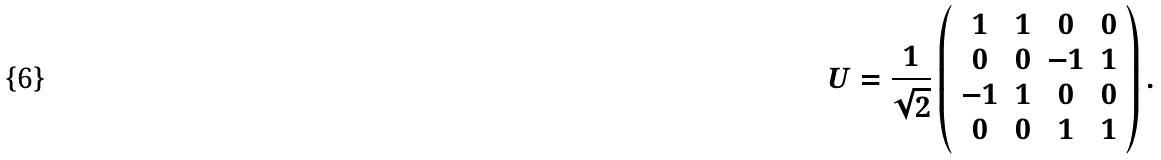<formula> <loc_0><loc_0><loc_500><loc_500>U = \frac { 1 } { \sqrt { 2 } } \left ( \begin{array} { c c c c } 1 & 1 & 0 & 0 \\ 0 & 0 & - 1 & 1 \\ - 1 & 1 & 0 & 0 \\ 0 & 0 & 1 & 1 \\ \end{array} \right ) .</formula> 